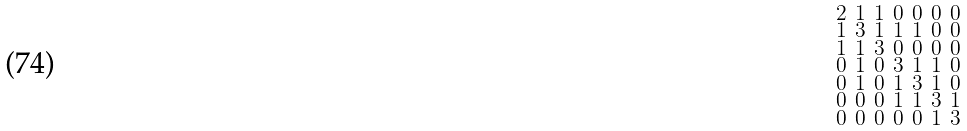Convert formula to latex. <formula><loc_0><loc_0><loc_500><loc_500>\begin{smallmatrix} 2 & 1 & 1 & 0 & 0 & 0 & 0 \\ 1 & 3 & 1 & 1 & 1 & 0 & 0 \\ 1 & 1 & 3 & 0 & 0 & 0 & 0 \\ 0 & 1 & 0 & 3 & 1 & 1 & 0 \\ 0 & 1 & 0 & 1 & 3 & 1 & 0 \\ 0 & 0 & 0 & 1 & 1 & 3 & 1 \\ 0 & 0 & 0 & 0 & 0 & 1 & 3 \end{smallmatrix}</formula> 